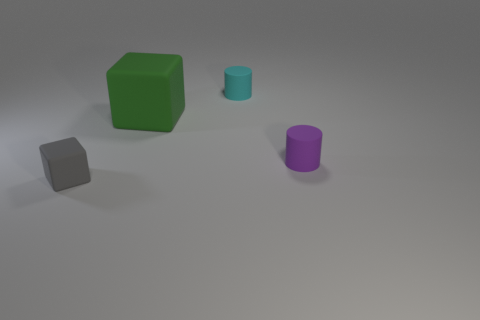There is a matte cylinder that is the same size as the cyan thing; what is its color?
Your response must be concise. Purple. Are there the same number of small cyan matte cylinders right of the cyan thing and gray rubber blocks in front of the large rubber cube?
Offer a terse response. No. What number of things are cyan rubber blocks or tiny purple matte cylinders?
Provide a short and direct response. 1. Is the number of small things less than the number of green rubber things?
Offer a terse response. No. What size is the cyan thing that is the same material as the green object?
Make the answer very short. Small. The gray cube is what size?
Ensure brevity in your answer.  Small. What shape is the cyan thing?
Your response must be concise. Cylinder. What size is the gray rubber thing that is the same shape as the big green rubber object?
Make the answer very short. Small. There is a rubber block that is behind the cube that is in front of the purple cylinder; are there any cyan cylinders that are in front of it?
Ensure brevity in your answer.  No. How many tiny things are purple metal things or green rubber objects?
Keep it short and to the point. 0. 